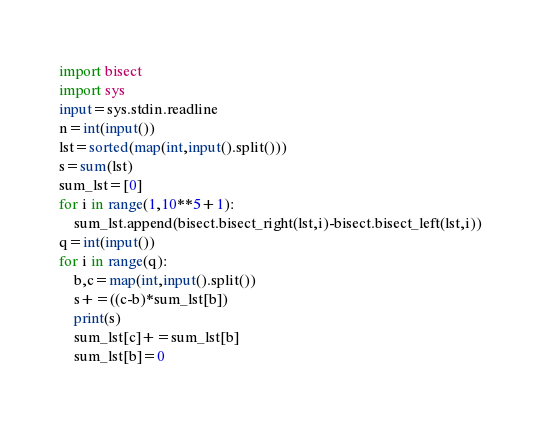<code> <loc_0><loc_0><loc_500><loc_500><_Python_>import bisect
import sys
input=sys.stdin.readline
n=int(input())
lst=sorted(map(int,input().split()))
s=sum(lst)
sum_lst=[0]
for i in range(1,10**5+1):
    sum_lst.append(bisect.bisect_right(lst,i)-bisect.bisect_left(lst,i))
q=int(input())
for i in range(q):
    b,c=map(int,input().split())
    s+=((c-b)*sum_lst[b])
    print(s)
    sum_lst[c]+=sum_lst[b]
    sum_lst[b]=0</code> 